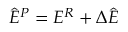<formula> <loc_0><loc_0><loc_500><loc_500>\hat { E } ^ { P } = E ^ { R } + \Delta \hat { E }</formula> 